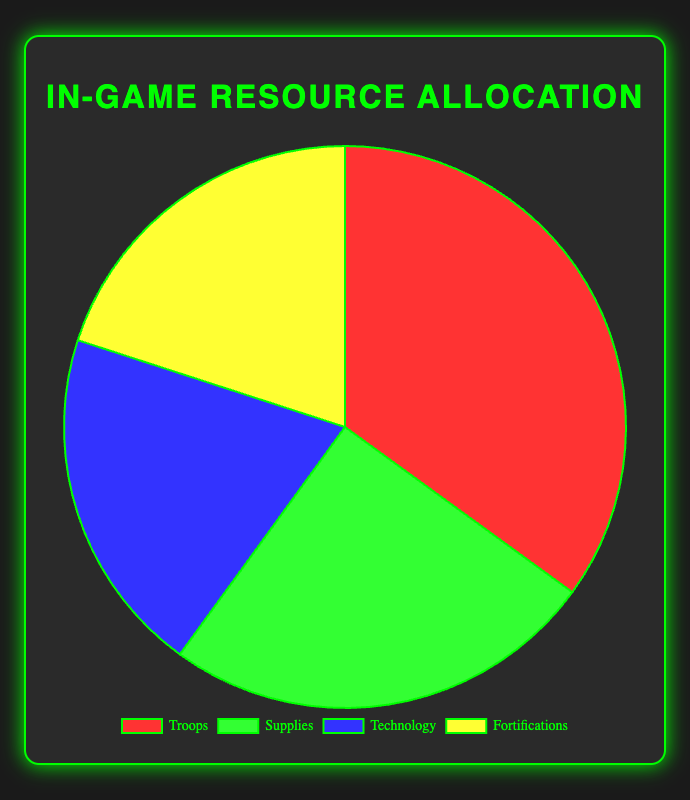What is the largest category by percentage in the pie chart? The largest category is the one with the highest percentage value. From the data provided, Troops account for 35%, which is the highest among all categories.
Answer: Troops Which two categories have equal percentage allocation? We need to find categories that have the same percentage value. According to the data, both Technology and Fortifications are allocated 20% each.
Answer: Technology and Fortifications What is the combined percentage of Supplies and Technology? To find the combined percentage, we add the values for Supplies and Technology. Supplies are 25% and Technology is 20%, so the total is 25% + 20% = 45%.
Answer: 45% Which category is represented by the green color in the pie chart? By referring to the visual information, the green color segment corresponds to Supplies.
Answer: Supplies How much greater is the percentage allocation of Troops compared to Fortifications? To find out how much greater, we subtract the percentage of Fortifications from Troops. The allocation for Troops is 35%, and for Fortifications, it is 20%. So, 35% - 20% = 15%.
Answer: 15% What are the two smallest categories by percentage? We identify the smallest percentages and name the corresponding categories. Both Technology and Fortifications are the smallest with 20% each.
Answer: Technology and Fortifications If Supplies' percentage is increased by 5%, what will be the new percentage? We add 5% to the original percentage of Supplies. The current percentage is 25%, so the new percentage would be 25% + 5% = 30%.
Answer: 30% What is the average percentage allocation for all categories? To find the average, we sum up all percentages and divide by the number of categories. The total is 35% + 25% + 20% + 20% = 100%. There are 4 categories, so 100% / 4 = 25%.
Answer: 25% Are Technology and Supplies combined allocation more than half of the total allocation? We sum the percentages for Technology and Supplies, which are 20% and 25%, respectively. Their combined allocation is 20% + 25% = 45%, which is less than 50%.
Answer: No Which category is represented by the yellow color in the pie chart? By referring to the visual information, the yellow color segment corresponds to Fortifications.
Answer: Fortifications 